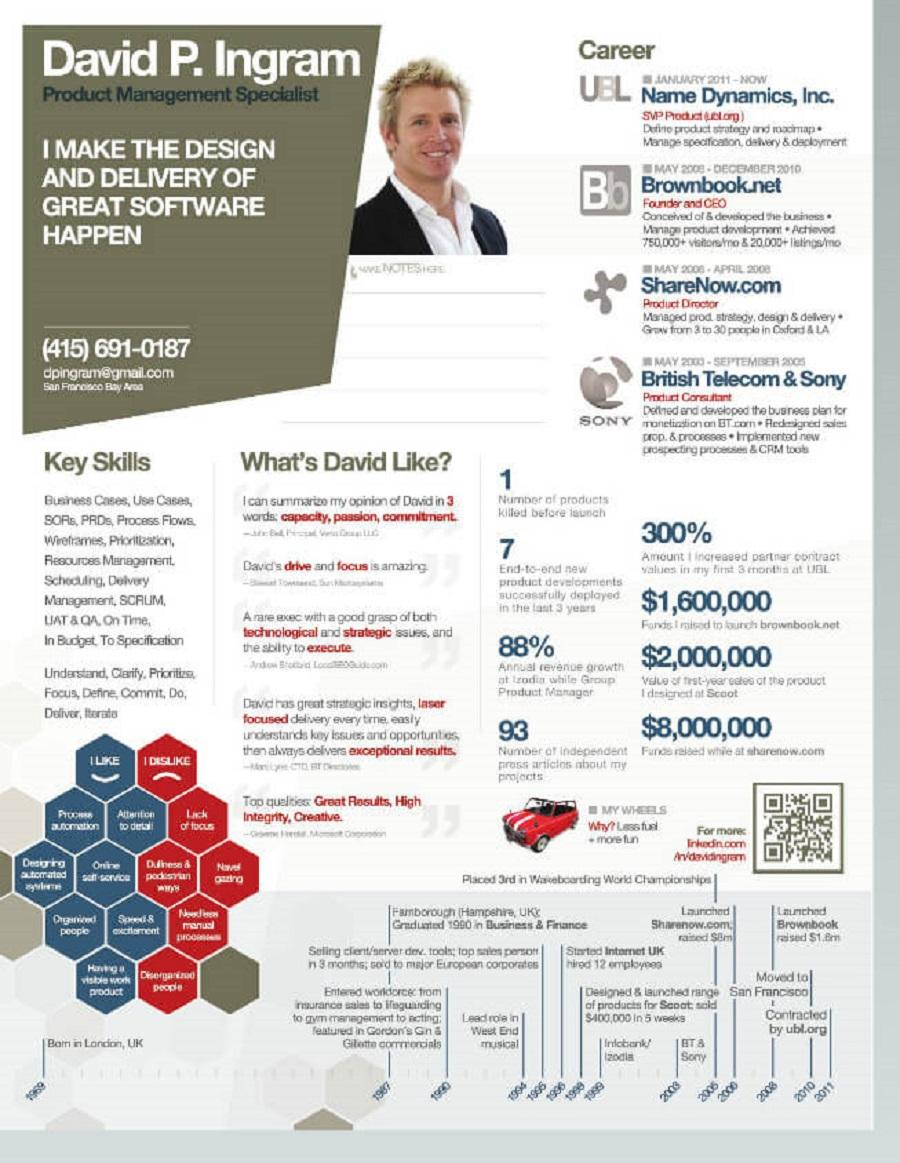Point out several critical features in this image. The first company of David was named SONY. There are five dislikes for David. How many likes of David are listed? There are 7 of them. The second company of David was known as ShareNow.com. 